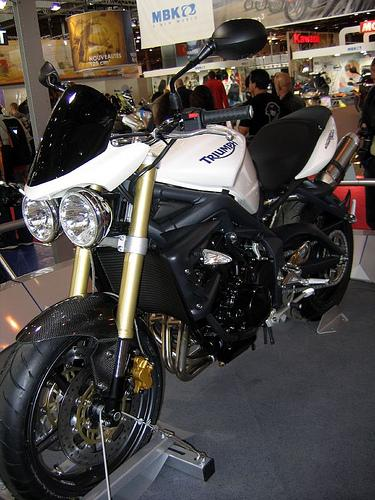What kind of bike is this?

Choices:
A) scooter
B) motorbike
C) bicycle
D) vespa motorbike 